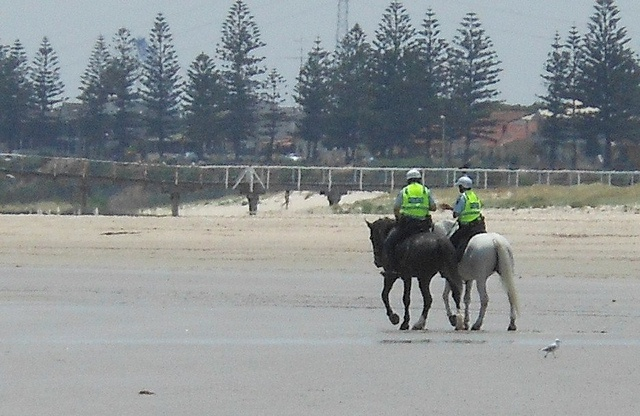Describe the objects in this image and their specific colors. I can see horse in lightblue, black, gray, darkgray, and lightgray tones, horse in lightblue, gray, darkgray, lightgray, and black tones, people in lightblue, black, teal, green, and darkgreen tones, people in lightblue, black, gray, green, and lightgreen tones, and bird in lightblue, darkgray, gray, and lightgray tones in this image. 